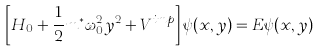Convert formula to latex. <formula><loc_0><loc_0><loc_500><loc_500>\left [ H _ { 0 } + \frac { 1 } { 2 } m ^ { * } \omega _ { 0 } ^ { 2 } y ^ { 2 } + V ^ { i m p } \right ] \psi ( x , y ) = E \psi ( x , y )</formula> 